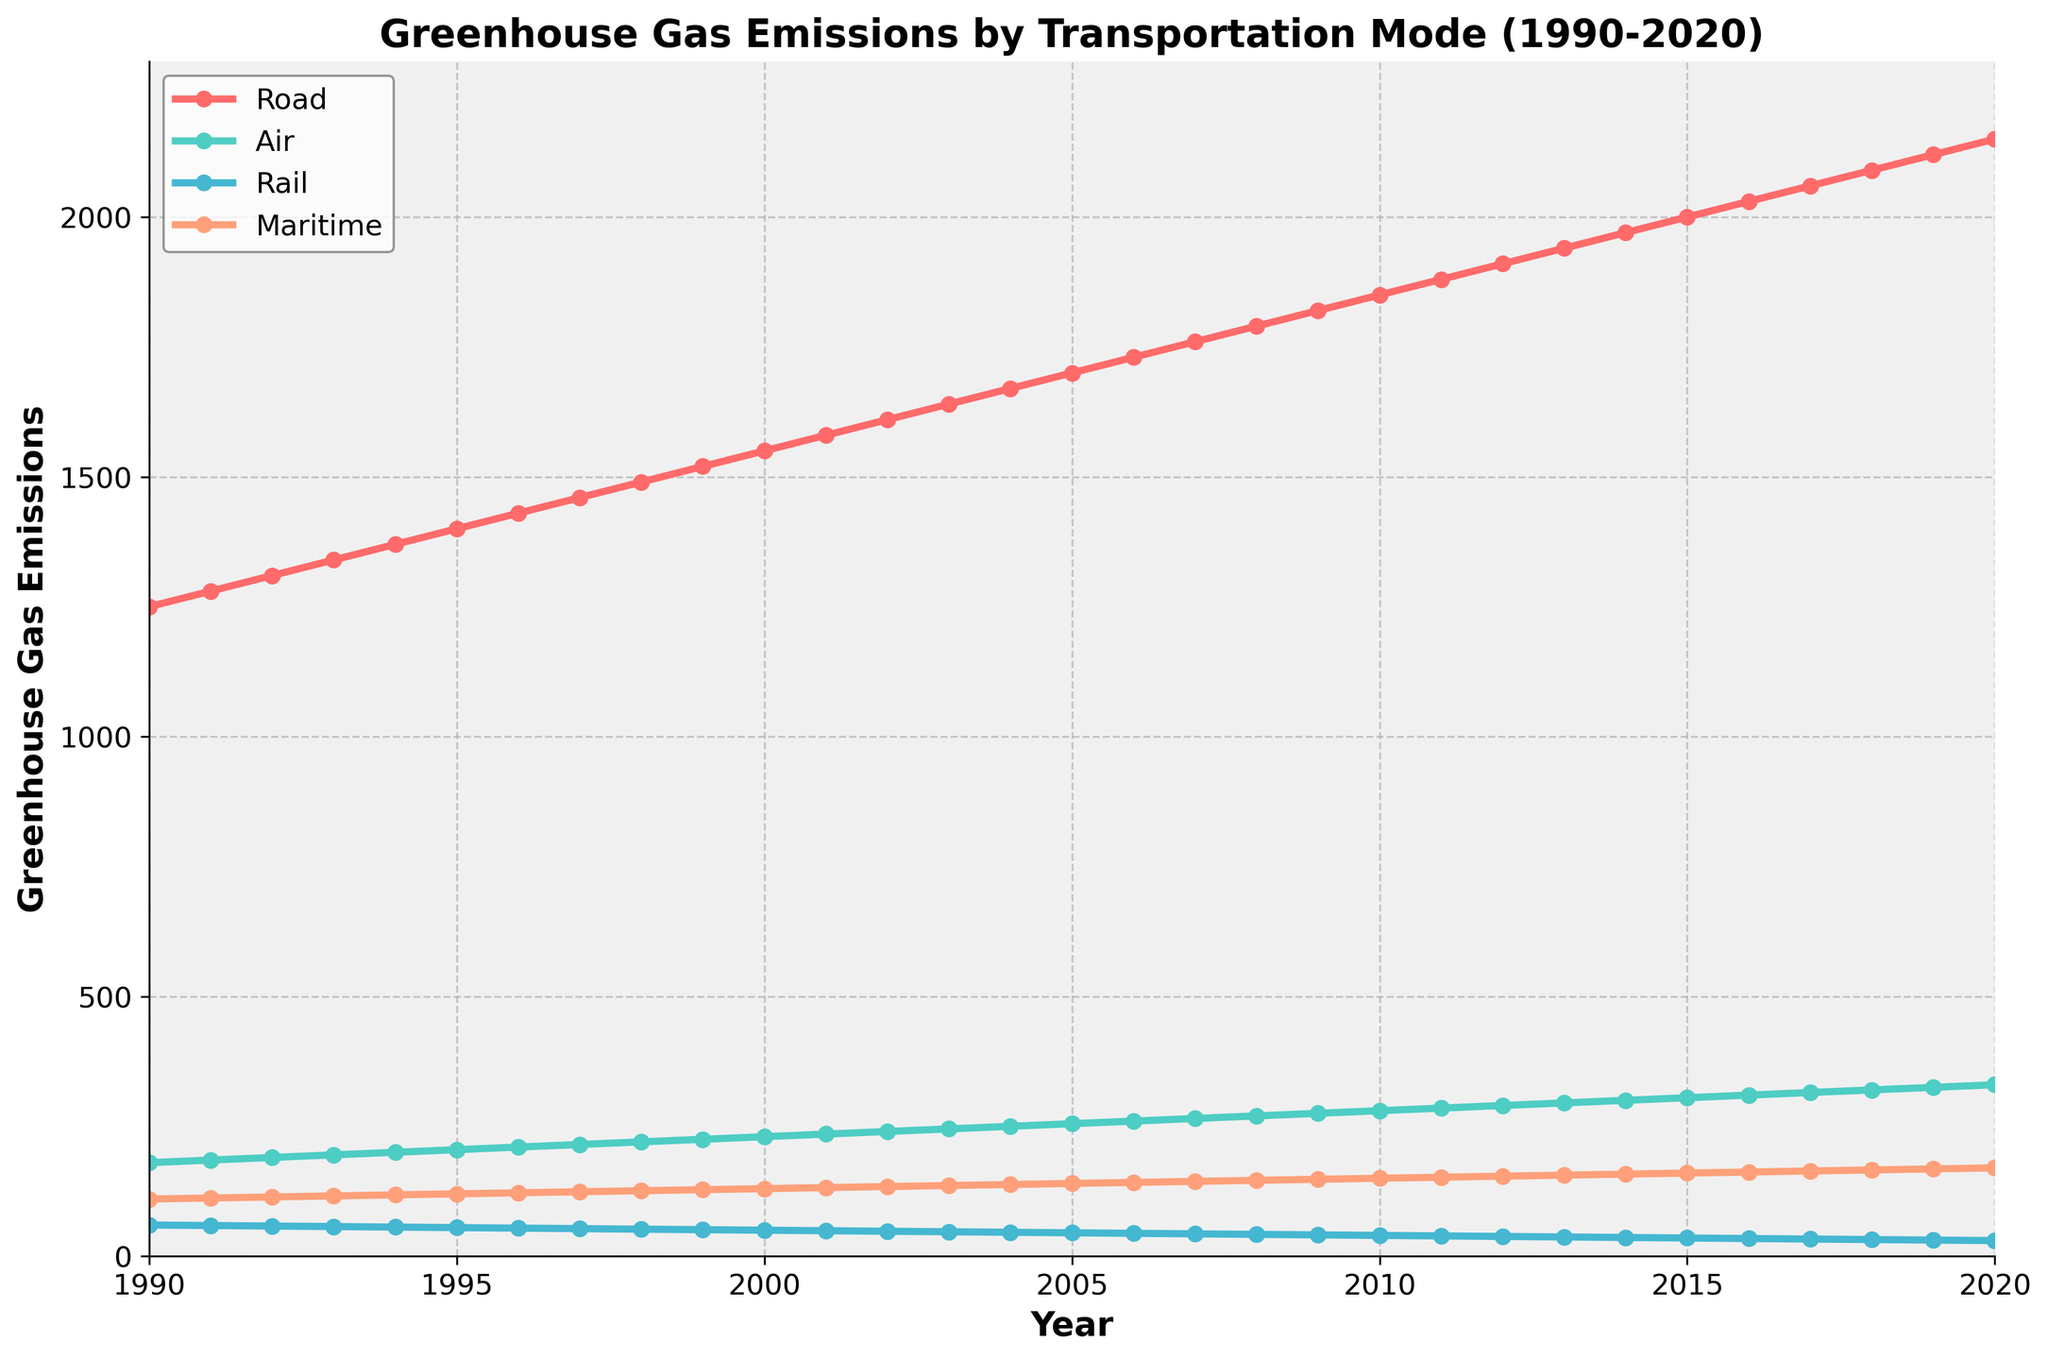What is the transportation mode with the highest greenhouse gas emissions in 2020? Looking at the plot, the highest line on the chart represents the transportation mode with the highest emissions. The "Road" transportation mode has the highest emissions in 2020.
Answer: Road How did greenhouse gas emissions from air transportation change from 1990 to 2020? To find this, compare the values at the start and end points of the air transportation line. In 1990, emissions were 180. In 2020, emissions were 330. The emissions increased by 150 over 30 years.
Answer: Increased by 150 Which transportation mode had the least greenhouse gas emissions in 2010, and what was the value? By observing the chart at the 2010 mark, the lowest line is for "Rail." The emissions for rail in 2010 were 40.
Answer: Rail, 40 Compare the trend of emissions from road transportation and maritime transportation between 1990 and 2020. Analyze the slope of both lines on the chart. Road emissions show a continuous increase, starting at 1250 and reaching 2150. Maritime emissions also increased, but more slowly, starting at 110 and reaching 170. Road emissions increased more sharply.
Answer: Road increased more sharply Between which years did rail transportation see the greatest reduction in greenhouse gas emissions? To identify this, look for the steepest downward segment in the rail emissions line on the chart. Rail emissions decreased most significantly from 1995 (55) to 1996 (54).
Answer: 1995 to 1996 What is the combined greenhouse gas emissions of all transportation modes in 2005? Add the values for each mode in 2005 from the chart. Road: 1700, Air: 255, Rail: 45, Maritime: 140. Summing them up: 1700 + 255 + 45 + 140 = 2140.
Answer: 2140 On average, how much did emissions from maritime transportation increase per year between 1990 and 2020? Calculate the total increase in emissions over the period and divide by the number of years. Increase: 170 - 110 = 60. Number of years: 30. Average increase per year: 60 / 30 = 2.
Answer: 2 Which transportation mode had a more stable trend in greenhouse gas emissions over the period 1990 to 2020? A stable trend indicates minimal fluctuations. Observing the chart, rail transportation's line is the flattest, suggesting the most stability with a gradual decrease.
Answer: Rail In which years did air transportation emissions surpass levels of 200 in the chart? Look for the points where the air emissions line crosses the 200 mark. It surpasses 200 in 1994 and continues to rise afterward.
Answer: 1994 onwards If the trend continues, what could be the possible emissions for rail transportation in 2025? Extrapolate the trend observed. Rail emissions have decreased linearly by 1 unit approximately every year. In 2020, emissions were 30. By 2025, it could be: 30 - (1 * 5) = 25.
Answer: 25 